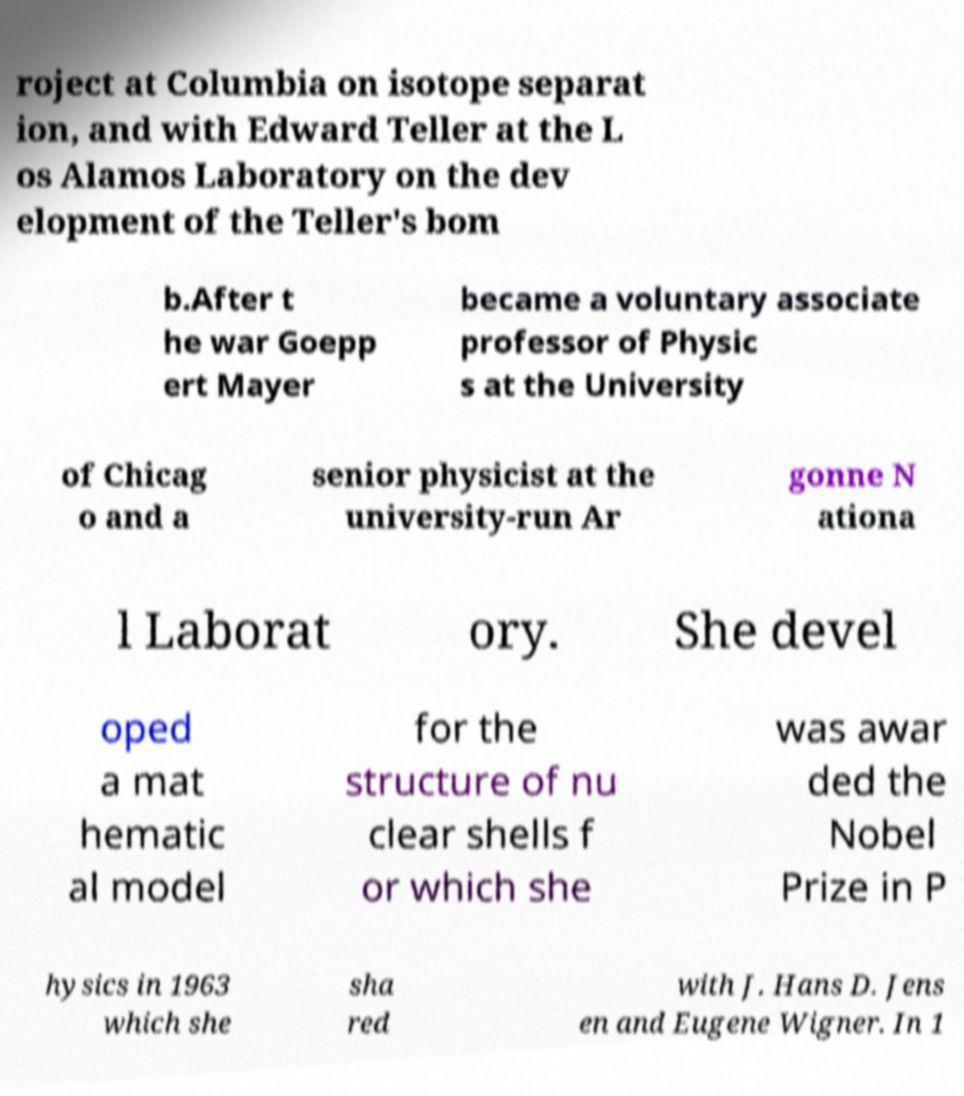I need the written content from this picture converted into text. Can you do that? roject at Columbia on isotope separat ion, and with Edward Teller at the L os Alamos Laboratory on the dev elopment of the Teller's bom b.After t he war Goepp ert Mayer became a voluntary associate professor of Physic s at the University of Chicag o and a senior physicist at the university-run Ar gonne N ationa l Laborat ory. She devel oped a mat hematic al model for the structure of nu clear shells f or which she was awar ded the Nobel Prize in P hysics in 1963 which she sha red with J. Hans D. Jens en and Eugene Wigner. In 1 